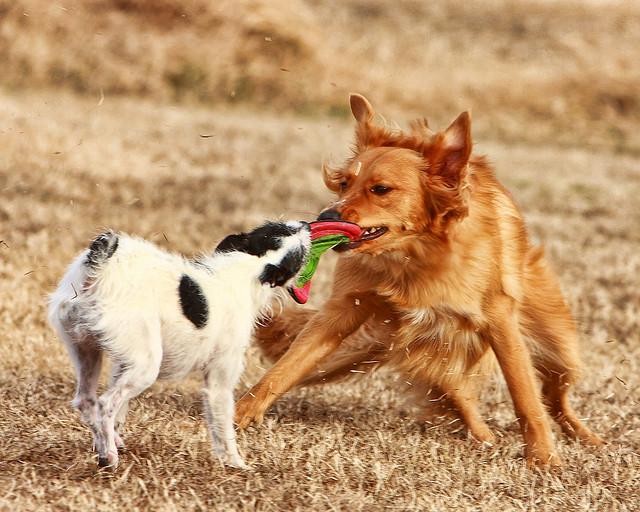What color is the smaller dog?
Write a very short answer. White and black. Will the bigger dog get the frisbee?
Concise answer only. Yes. Is this a grassy field?
Be succinct. Yes. 